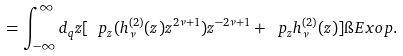<formula> <loc_0><loc_0><loc_500><loc_500>= \int _ { - \infty } ^ { \infty } d _ { q } z [ \ p _ { z } ( h _ { \nu } ^ { ( 2 ) } ( z ) z ^ { 2 \nu + 1 } ) z ^ { - 2 \nu + 1 } + \ p _ { z } h _ { \nu } ^ { ( 2 ) } ( z ) ] \i E x o p .</formula> 